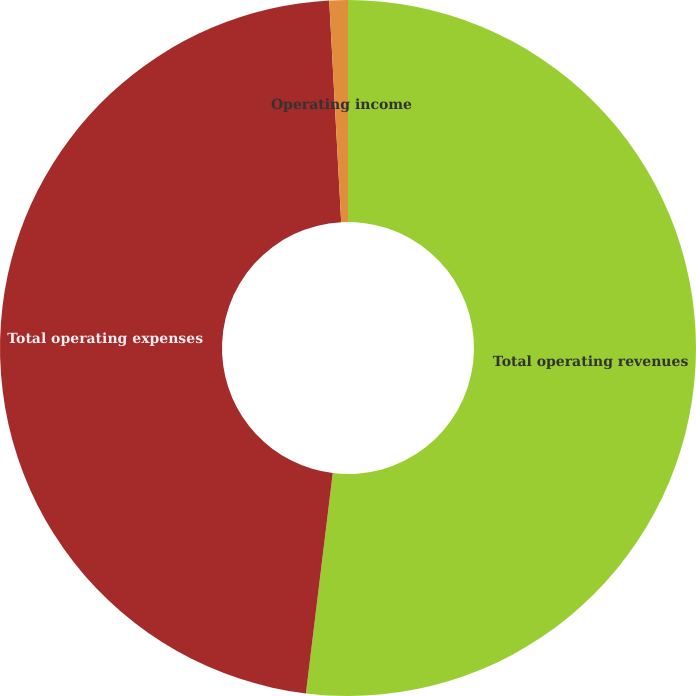Convert chart. <chart><loc_0><loc_0><loc_500><loc_500><pie_chart><fcel>Total operating revenues<fcel>Total operating expenses<fcel>Operating income<nl><fcel>51.93%<fcel>47.21%<fcel>0.86%<nl></chart> 